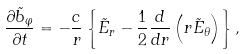<formula> <loc_0><loc_0><loc_500><loc_500>\frac { \partial \tilde { b } _ { \varphi } } { \partial t } = - \frac { c } { r } \left \{ \tilde { E } _ { r } - \frac { 1 } { 2 } \frac { d } { d r } \left ( r \tilde { E } _ { \theta } \right ) \right \} ,</formula> 